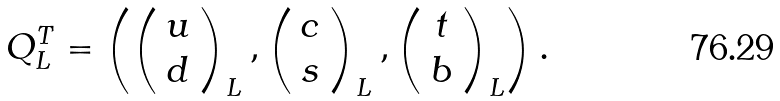<formula> <loc_0><loc_0><loc_500><loc_500>Q _ { L } ^ { T } = \left ( \left ( \begin{array} { c } u \\ d \end{array} \right ) _ { L } , \left ( \begin{array} { c } c \\ s \end{array} \right ) _ { L } , \left ( \begin{array} { c } t \\ b \end{array} \right ) _ { L } \right ) .</formula> 